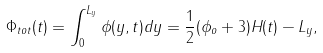<formula> <loc_0><loc_0><loc_500><loc_500>\Phi _ { t o t } ( t ) = \int _ { 0 } ^ { L _ { y } } \phi ( y , t ) d y = \frac { 1 } { 2 } ( \phi _ { o } + 3 ) H ( t ) - L _ { y } ,</formula> 